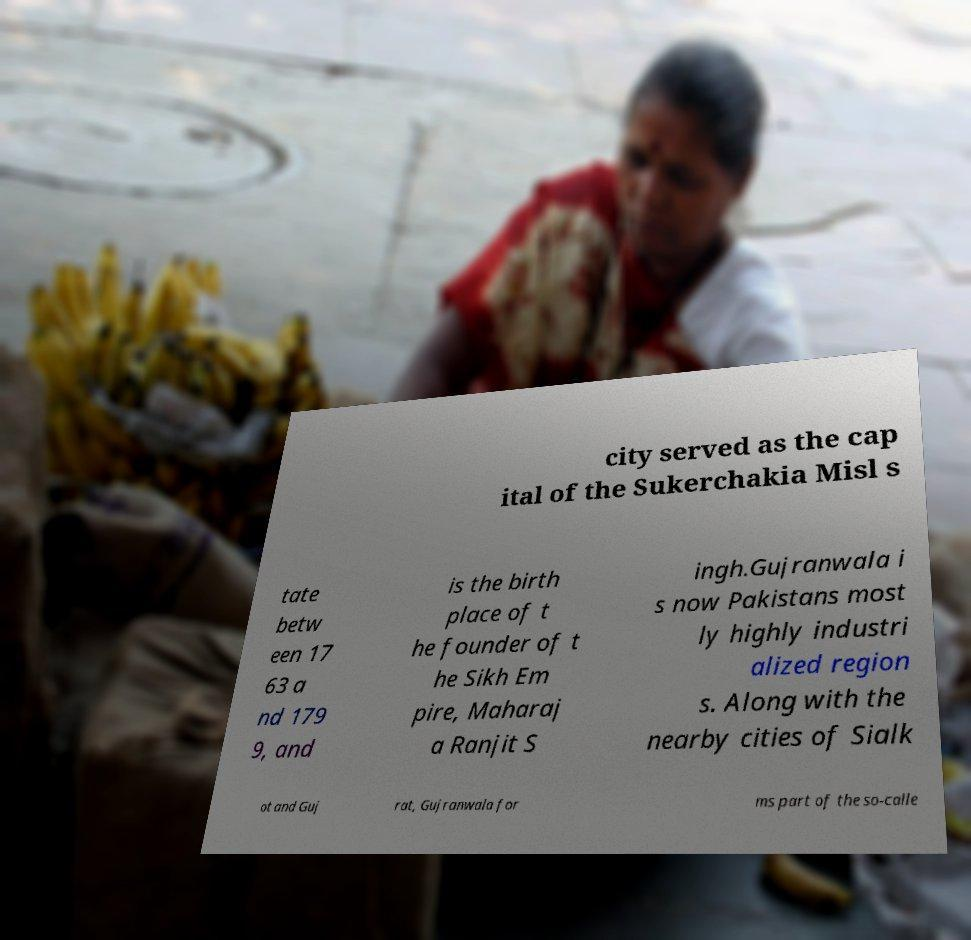There's text embedded in this image that I need extracted. Can you transcribe it verbatim? city served as the cap ital of the Sukerchakia Misl s tate betw een 17 63 a nd 179 9, and is the birth place of t he founder of t he Sikh Em pire, Maharaj a Ranjit S ingh.Gujranwala i s now Pakistans most ly highly industri alized region s. Along with the nearby cities of Sialk ot and Guj rat, Gujranwala for ms part of the so-calle 